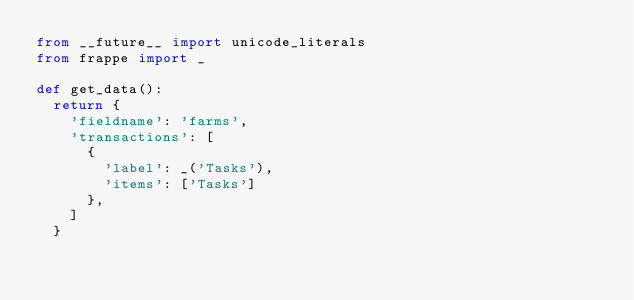<code> <loc_0><loc_0><loc_500><loc_500><_Python_>from __future__ import unicode_literals
from frappe import _

def get_data():
	return {
		'fieldname': 'farms',
		'transactions': [
			{
				'label': _('Tasks'),
				'items': ['Tasks']
			},
		]
	}</code> 